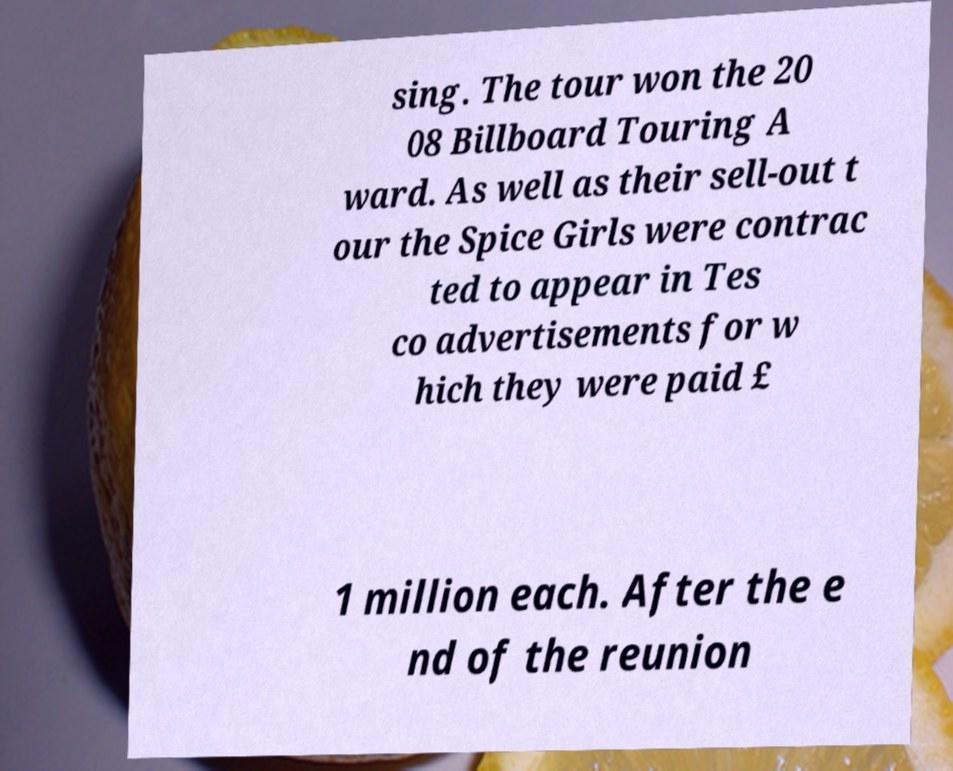Please read and relay the text visible in this image. What does it say? sing. The tour won the 20 08 Billboard Touring A ward. As well as their sell-out t our the Spice Girls were contrac ted to appear in Tes co advertisements for w hich they were paid £ 1 million each. After the e nd of the reunion 